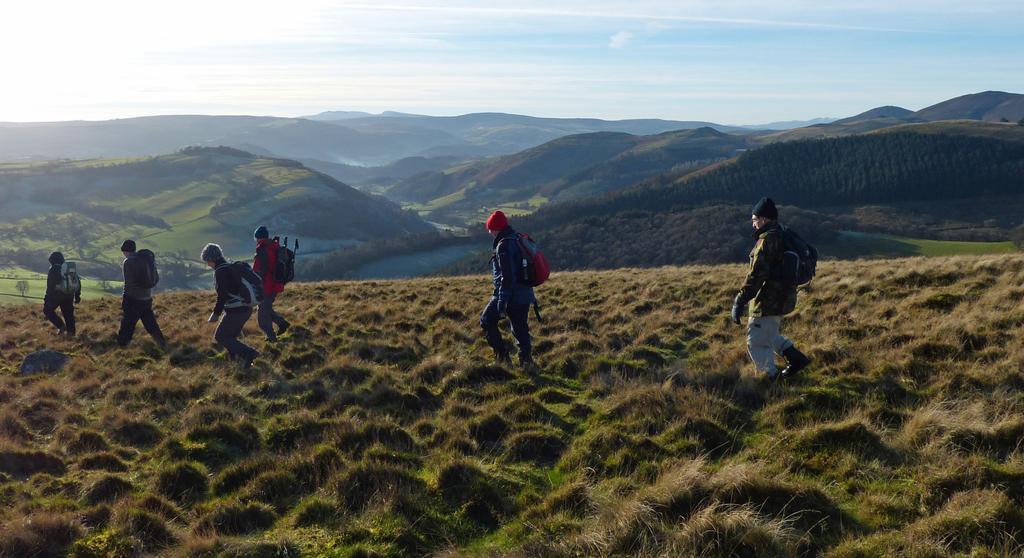Could you give a brief overview of what you see in this image? In this picture we can see a group of people carrying bags and walking on the ground and in the background we can see mountains, trees, sky with clouds. 